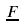<formula> <loc_0><loc_0><loc_500><loc_500>\underline { F }</formula> 